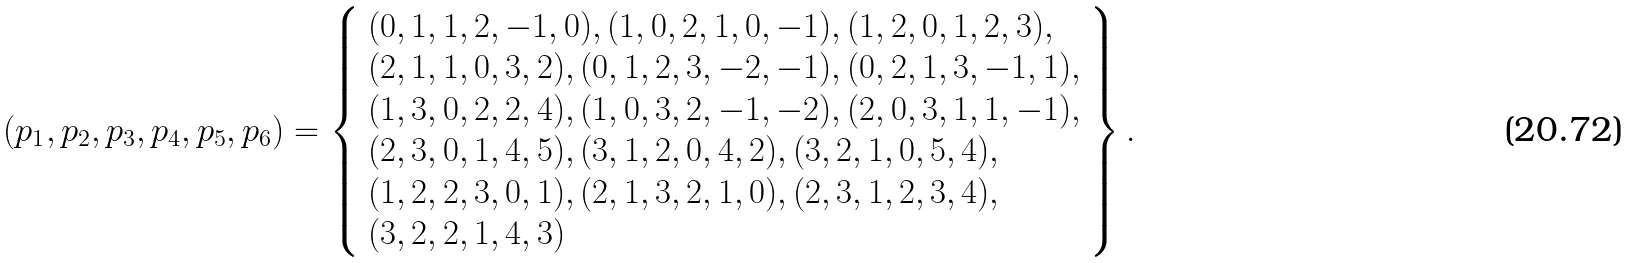<formula> <loc_0><loc_0><loc_500><loc_500>( p _ { 1 } , p _ { 2 } , p _ { 3 } , p _ { 4 } , p _ { 5 } , p _ { 6 } ) = \left \{ \begin{array} { l } ( 0 , 1 , 1 , 2 , - 1 , 0 ) , ( 1 , 0 , 2 , 1 , 0 , - 1 ) , ( 1 , 2 , 0 , 1 , 2 , 3 ) , \\ ( 2 , 1 , 1 , 0 , 3 , 2 ) , ( 0 , 1 , 2 , 3 , - 2 , - 1 ) , ( 0 , 2 , 1 , 3 , - 1 , 1 ) , \\ ( 1 , 3 , 0 , 2 , 2 , 4 ) , ( 1 , 0 , 3 , 2 , - 1 , - 2 ) , ( 2 , 0 , 3 , 1 , 1 , - 1 ) , \\ ( 2 , 3 , 0 , 1 , 4 , 5 ) , ( 3 , 1 , 2 , 0 , 4 , 2 ) , ( 3 , 2 , 1 , 0 , 5 , 4 ) , \\ ( 1 , 2 , 2 , 3 , 0 , 1 ) , ( 2 , 1 , 3 , 2 , 1 , 0 ) , ( 2 , 3 , 1 , 2 , 3 , 4 ) , \\ ( 3 , 2 , 2 , 1 , 4 , 3 ) \end{array} \right \} .</formula> 